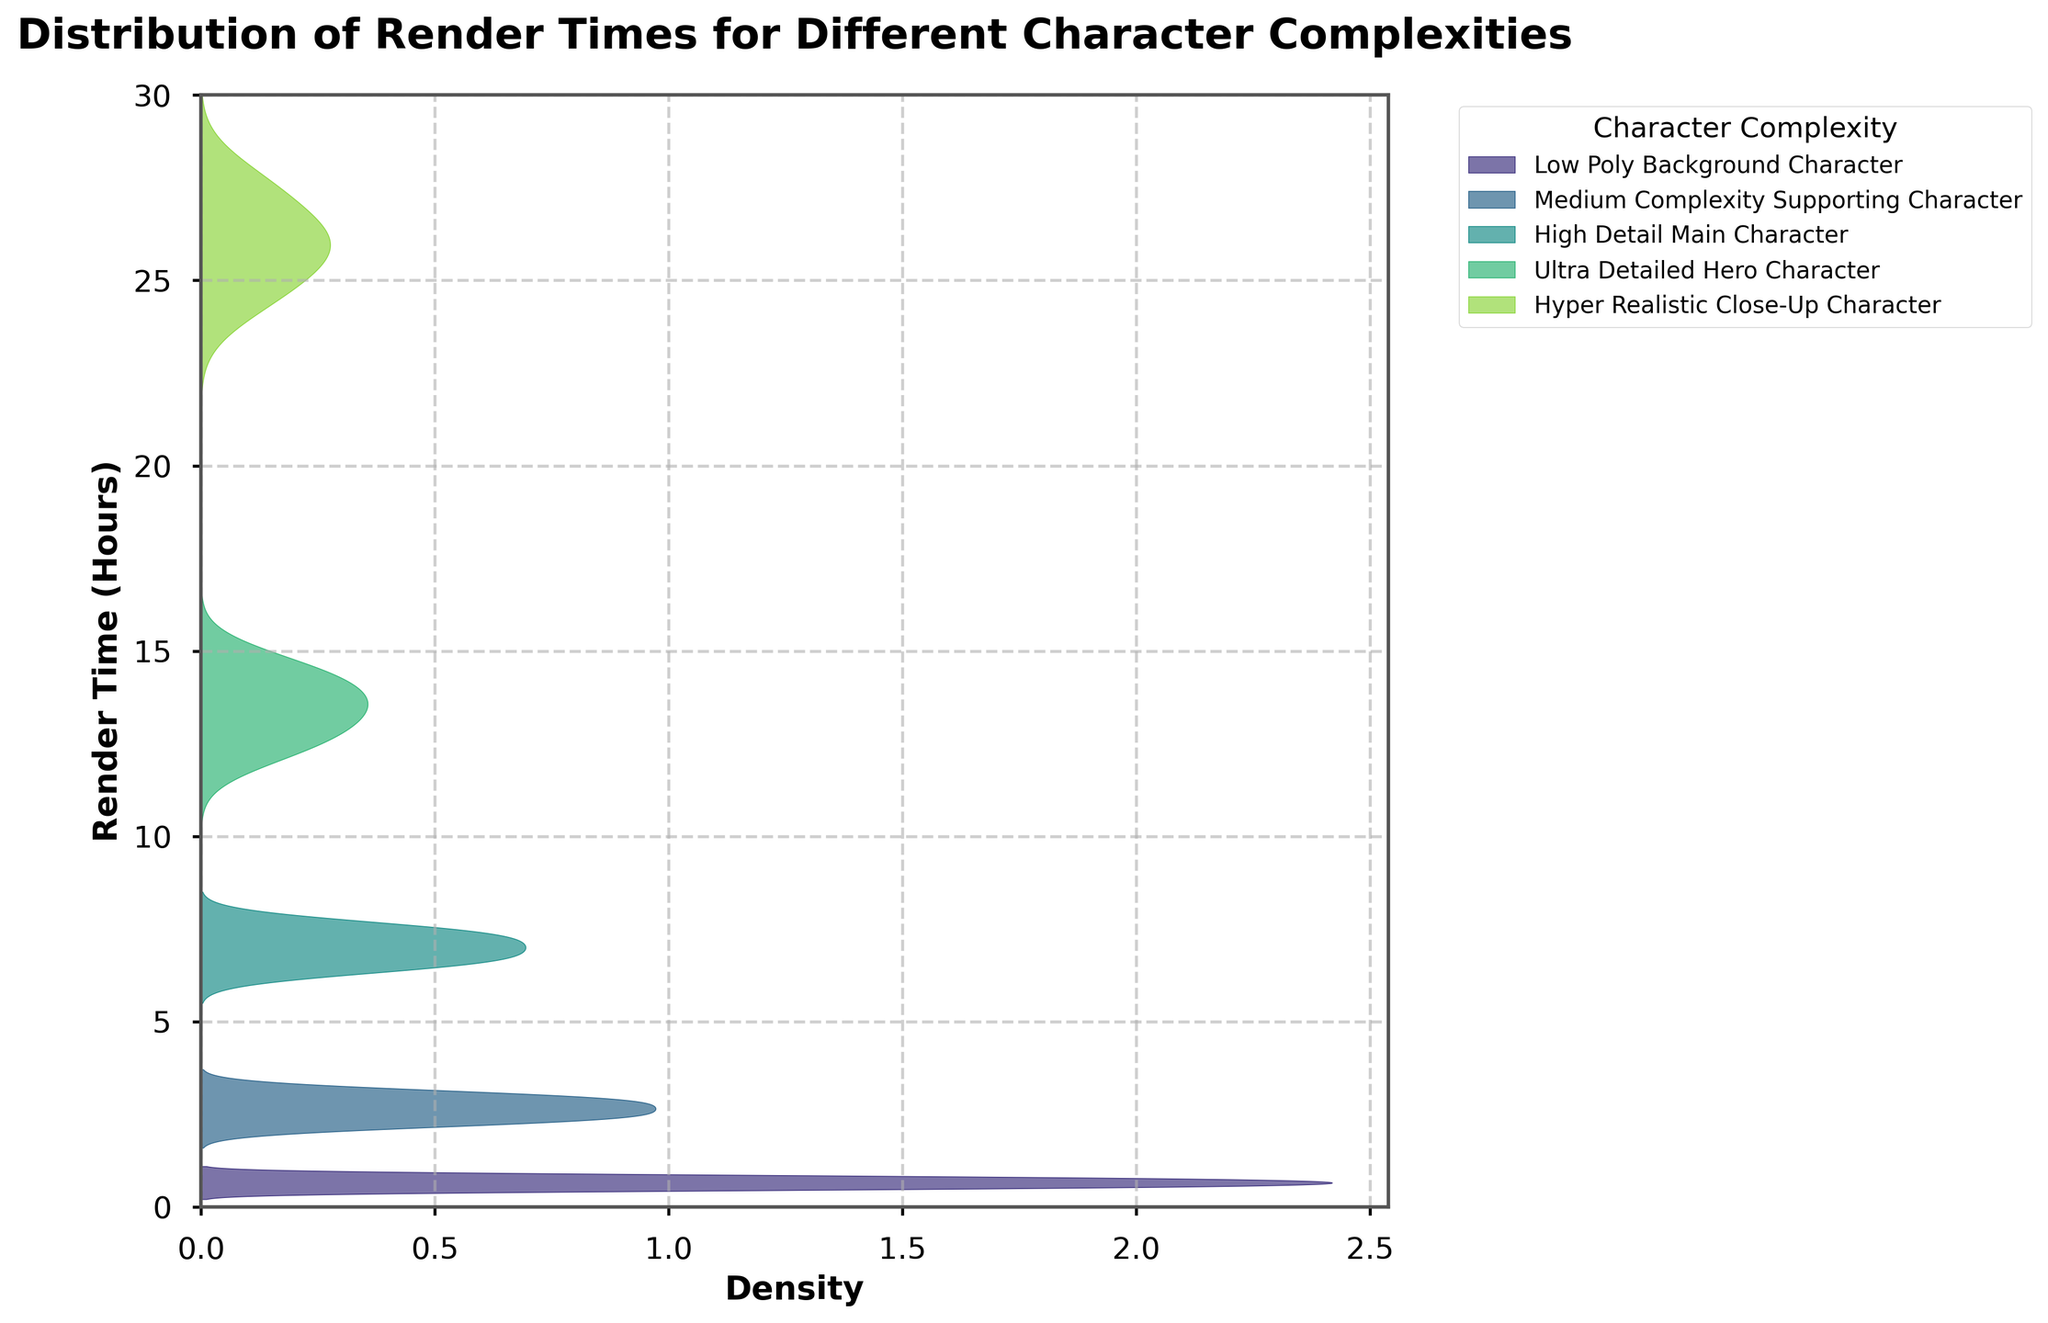What is the title of the figure? The title is located at the top of the figure and reads "Distribution of Render Times for Different Character Complexities".
Answer: Distribution of Render Times for Different Character Complexities Which character complexity has the highest central render time? The central render time for each complexity can be approximated by observing the peak of each density plot. The highest peak render time appears around 26 hours for "Hyper Realistic Close-Up Character".
Answer: Hyper Realistic Close-Up Character What is the range of render times for Low Poly Background Characters? By examining the shaded density plot for "Low Poly Background Characters", the non-zero density range starts at approximately 0.5 hours and ends at 0.8 hours.
Answer: 0.5 to 0.8 hours How does the median render time of High Detail Main Characters compare to the median render time of Medium Complexity Supporting Characters? The median render time can be approximated by the central value around which each density plot is most symmetric. For High Detail Main Characters, it's around 7 hours, and for Medium Complexity Supporting Characters, it's around 2.8 hours. Thus, the High Detail Main Characters have a higher median render time.
Answer: Higher Which complexity has the most spread-out range of render times? The spread of render times can be inferred by the width of each density plot. The "Hyper Realistic Close-Up Character" has the widest range, spreading from approximately 24.6 to 27.5 hours.
Answer: Hyper Realistic Close-Up Character Is the density plot for Ultra Detailed Hero Characters skewed left or right? A density plot is left-skewed if the tail is on the left and right-skewed if the tail is on the right. The Ultra Detailed Hero Characters plot has a longer right tail, indicating a right skew.
Answer: Right-skewed What is the approximate range of the highest density for Ultra Detailed Hero Character? The highest density refers to the peak area of the density plot. For Ultra Detailed Hero Characters, the highest density is around the central peak, between approximately 13.8 and 14.5 hours.
Answer: 13.8 to 14.5 hours 